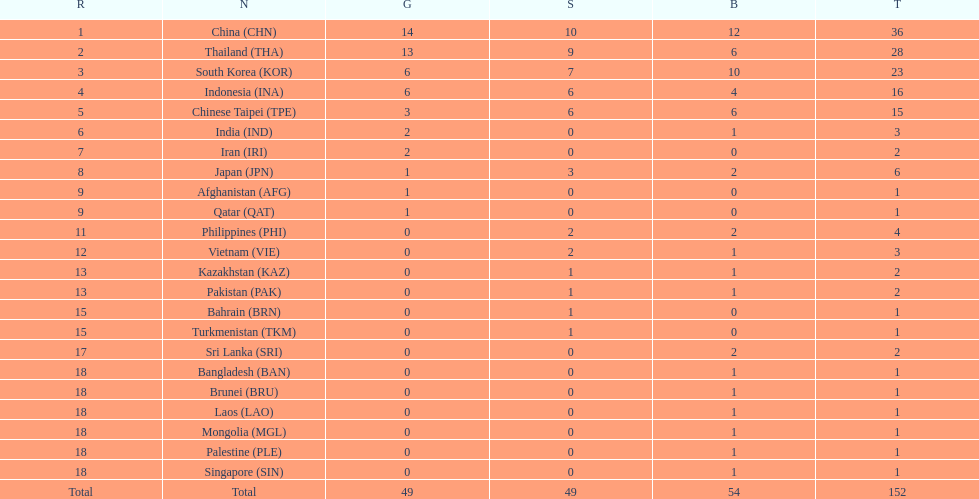How many nations won no silver medals at all? 11. 